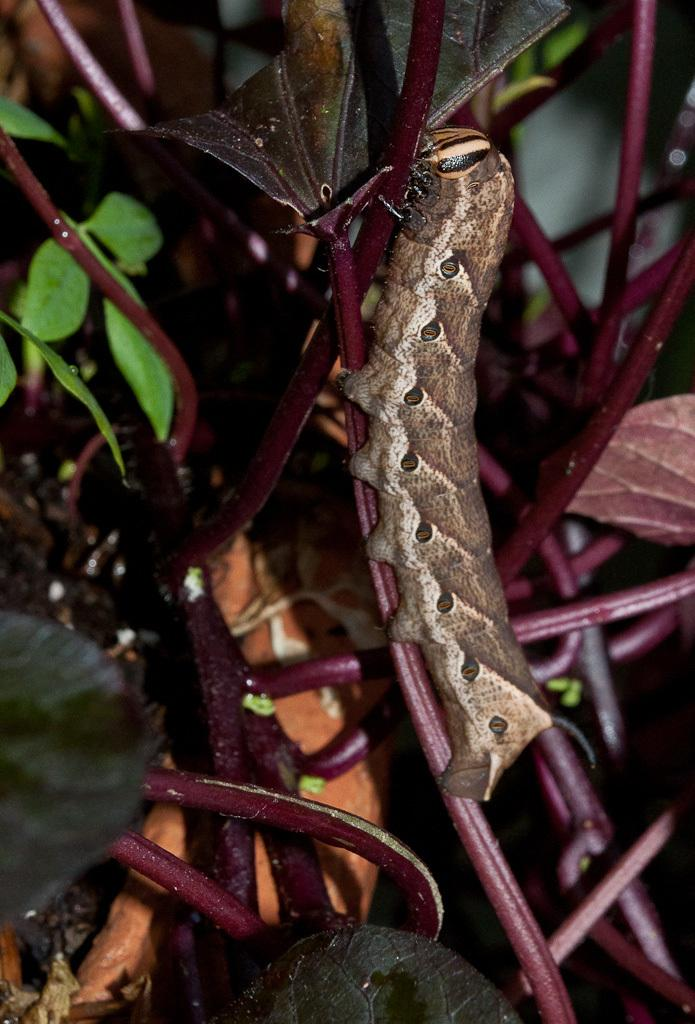What is present in the image? There is a plant in the image. What is on the plant? There is an insect on the plant. What type of insect is it? The insect appears to be a caterpillar. Can you see your dad holding a bone in the image? There is no mention of a dad or a bone in the image; it only features a plant and a caterpillar. 